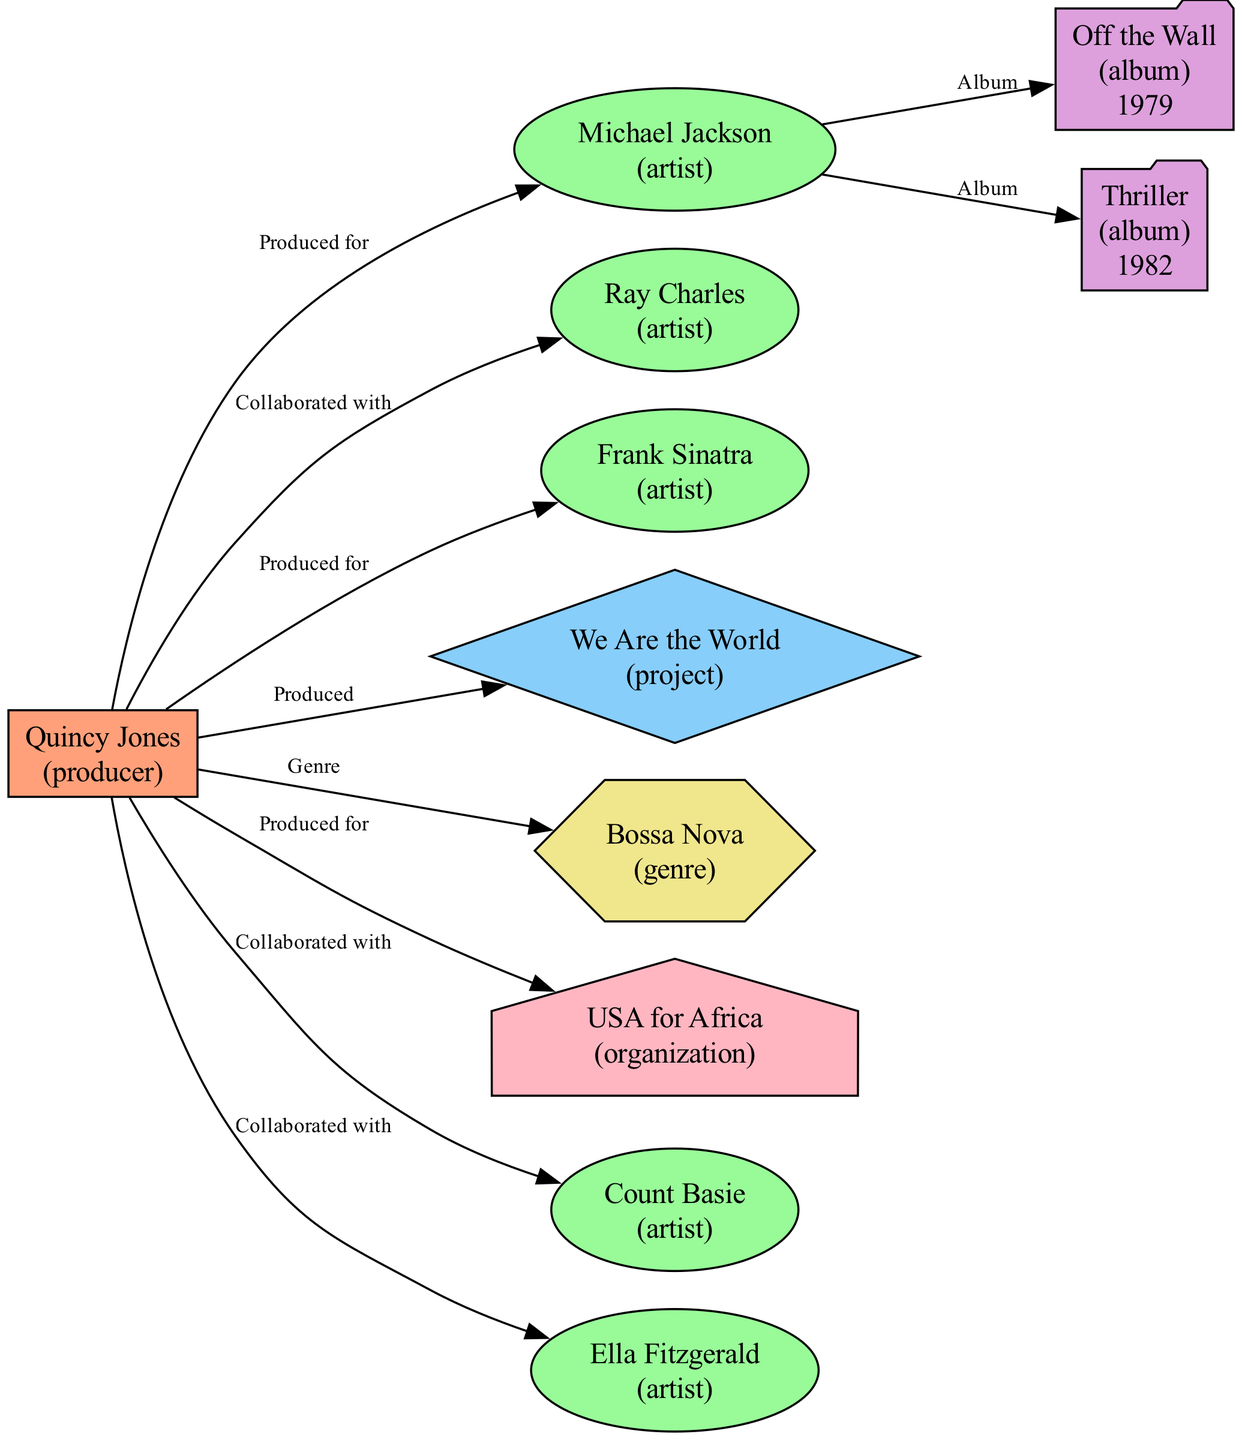What is the total number of nodes in the diagram? By counting all unique entities in the diagram, I find there are 11 nodes representing various artists, projects, albums, and genres.
Answer: 11 Who is the primary producer in the network? The label of the producer node labeled "1" indicates Quincy Jones is the central figure in this network map.
Answer: Quincy Jones How many artists has Quincy Jones collaborated with? By examining the edges connected to the producer node, there are four distinct artists connected to Quincy Jones—Michael Jackson, Ray Charles, Count Basie, and Ella Fitzgerald.
Answer: 4 What genre is Quincy Jones associated with? Looking at the edges connected to Quincy Jones, there is a link to the genre node labeled "Bossa Nova," which categorizes his work in this stylistic category.
Answer: Bossa Nova What year was the album "Thriller" released? The album node with the label "Thriller" contains the year value "1982," indicating when it was released.
Answer: 1982 Which organization is linked to Quincy Jones in the diagram? The node labeled "USA for Africa" shows a direct connection from Quincy Jones, indicating his involvement with that organization.
Answer: USA for Africa How many albums are mentioned in the diagram? Upon reviewing the nodes, I identify two albums mentioned: "Off the Wall" and "Thriller," both linked to Michael Jackson.
Answer: 2 Which artist did Quincy Jones not produce for? Reviewing the artist nodes and their connections, while he collaborated with many, he has not produced for Count Basie.
Answer: Count Basie What project is indicated in the diagram that Quincy Jones produced? The node labeled "We Are the World" connects directly to Quincy Jones, highlighting his production involvement in this prominent project.
Answer: We Are the World 